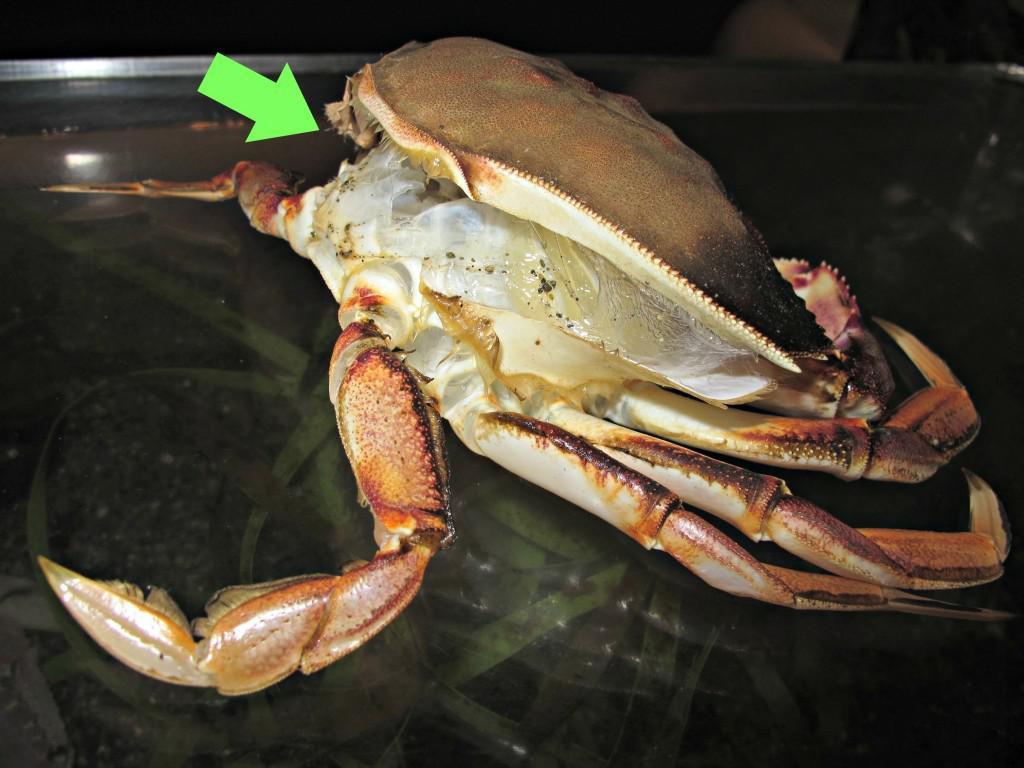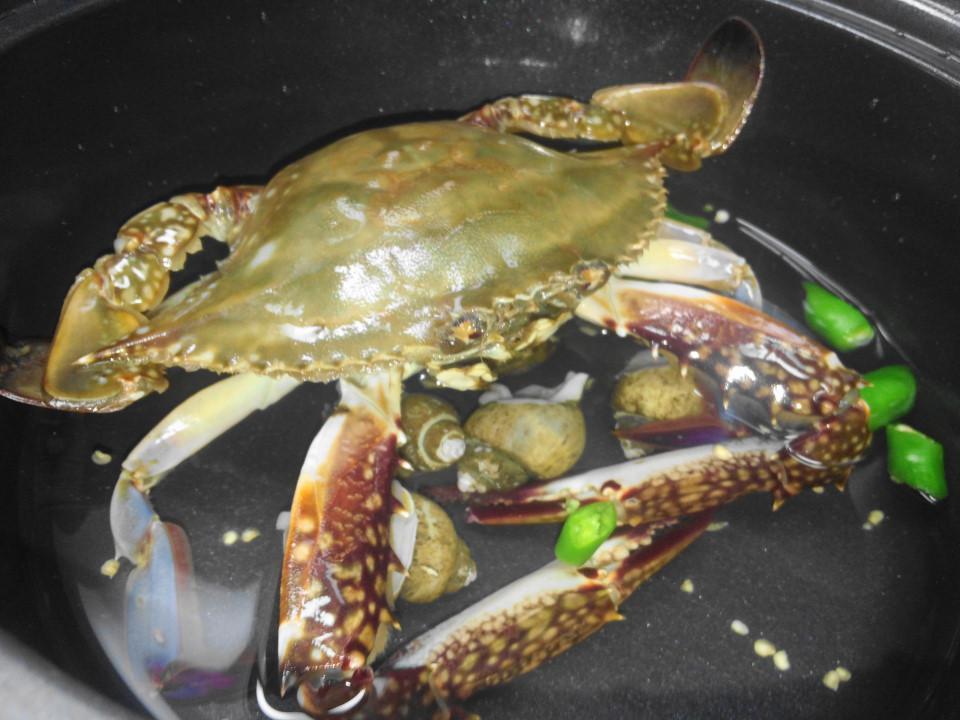The first image is the image on the left, the second image is the image on the right. Given the left and right images, does the statement "One image shows a hand next to the top of an intact crab, and the other image shows two hands tearing a crab in two." hold true? Answer yes or no. No. The first image is the image on the left, the second image is the image on the right. Given the left and right images, does the statement "One crab is being held by a human." hold true? Answer yes or no. No. 